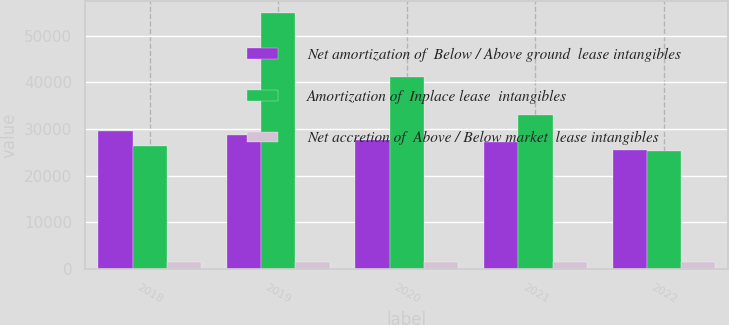Convert chart to OTSL. <chart><loc_0><loc_0><loc_500><loc_500><stacked_bar_chart><ecel><fcel>2018<fcel>2019<fcel>2020<fcel>2021<fcel>2022<nl><fcel>Net amortization of  Below / Above ground  lease intangibles<fcel>29654<fcel>28754<fcel>27710<fcel>27106<fcel>25440<nl><fcel>Amortization of  Inplace lease  intangibles<fcel>26273<fcel>54743<fcel>41211<fcel>32893<fcel>25202<nl><fcel>Net accretion of  Above / Below market  lease intangibles<fcel>1560<fcel>1550<fcel>1544<fcel>1545<fcel>1555<nl></chart> 